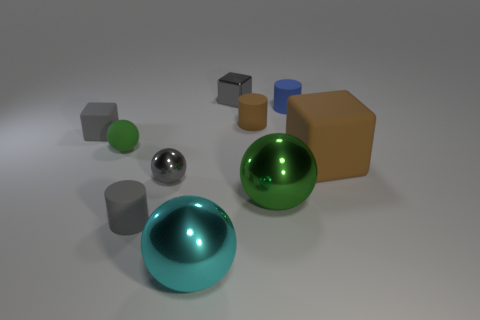Subtract 1 spheres. How many spheres are left? 3 Subtract all cylinders. How many objects are left? 7 Subtract 0 cyan cylinders. How many objects are left? 10 Subtract all cyan matte blocks. Subtract all brown matte blocks. How many objects are left? 9 Add 8 large brown rubber cubes. How many large brown rubber cubes are left? 9 Add 6 purple rubber cylinders. How many purple rubber cylinders exist? 6 